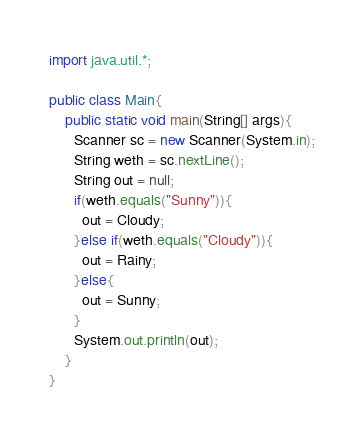Convert code to text. <code><loc_0><loc_0><loc_500><loc_500><_Java_>import java.util.*;

public class Main{
	public static void main(String[] args){
      Scanner sc = new Scanner(System.in);
      String weth = sc.nextLine();
      String out = null;
      if(weth.equals("Sunny")){
        out = Cloudy;
      }else if(weth.equals("Cloudy")){
        out = Rainy;
      }else{
        out = Sunny;
      }
      System.out.println(out);
    }
}</code> 